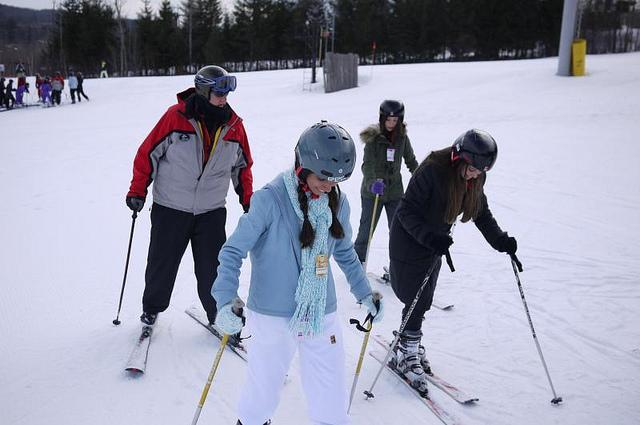What is this group ready to do?

Choices:
A) descend
B) run
C) ascend
D) duck descend 